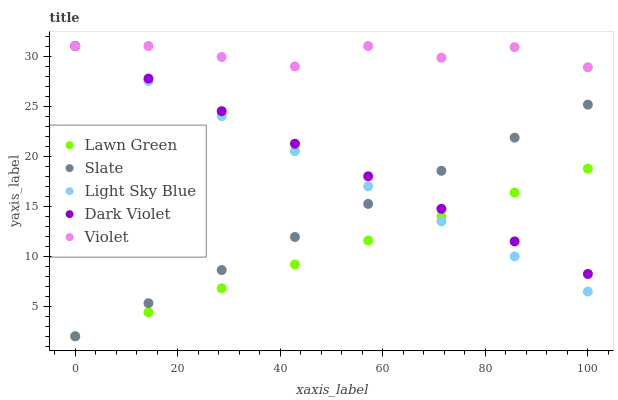Does Lawn Green have the minimum area under the curve?
Answer yes or no. Yes. Does Violet have the maximum area under the curve?
Answer yes or no. Yes. Does Slate have the minimum area under the curve?
Answer yes or no. No. Does Slate have the maximum area under the curve?
Answer yes or no. No. Is Light Sky Blue the smoothest?
Answer yes or no. Yes. Is Violet the roughest?
Answer yes or no. Yes. Is Slate the smoothest?
Answer yes or no. No. Is Slate the roughest?
Answer yes or no. No. Does Lawn Green have the lowest value?
Answer yes or no. Yes. Does Light Sky Blue have the lowest value?
Answer yes or no. No. Does Violet have the highest value?
Answer yes or no. Yes. Does Slate have the highest value?
Answer yes or no. No. Is Slate less than Violet?
Answer yes or no. Yes. Is Violet greater than Lawn Green?
Answer yes or no. Yes. Does Dark Violet intersect Lawn Green?
Answer yes or no. Yes. Is Dark Violet less than Lawn Green?
Answer yes or no. No. Is Dark Violet greater than Lawn Green?
Answer yes or no. No. Does Slate intersect Violet?
Answer yes or no. No. 